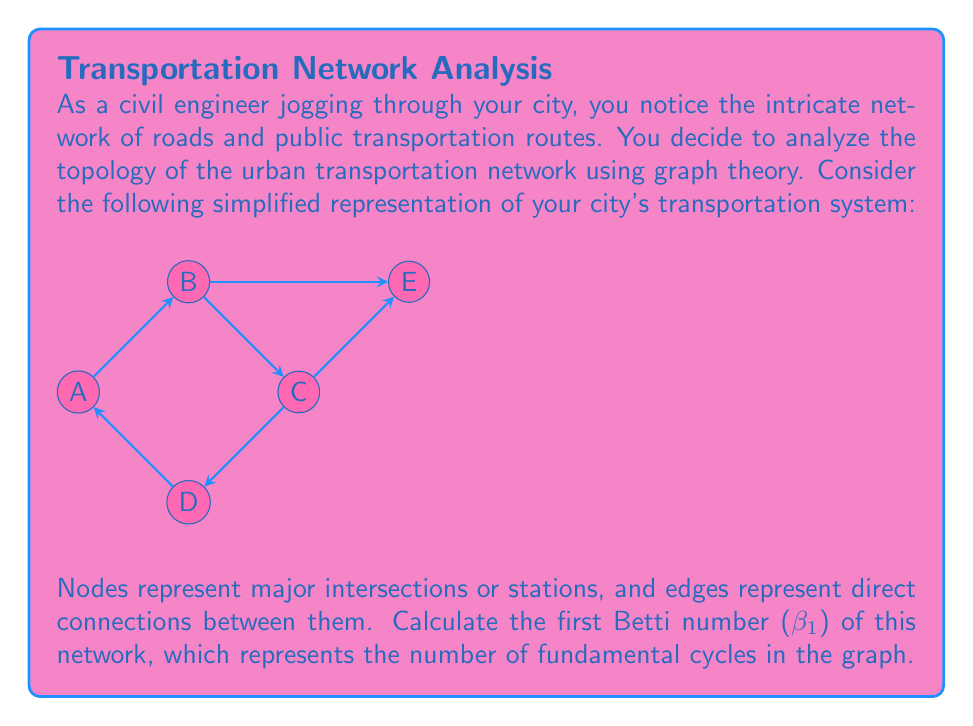Teach me how to tackle this problem. To calculate the first Betti number (β₁) of the graph, we'll follow these steps:

1. Recall the formula for the first Betti number of a graph:
   $$\beta_1 = |E| - |V| + 1$$
   where |E| is the number of edges and |V| is the number of vertices.

2. Count the number of vertices (|V|):
   The graph has 5 vertices (A, B, C, D, E).
   $$|V| = 5$$

3. Count the number of edges (|E|):
   The graph has 6 edges (A-B, B-C, C-D, D-A, B-E, C-E).
   $$|E| = 6$$

4. Apply the formula:
   $$\beta_1 = |E| - |V| + 1$$
   $$\beta_1 = 6 - 5 + 1$$
   $$\beta_1 = 2$$

5. Interpret the result:
   The first Betti number being 2 indicates that there are two fundamental cycles in the graph. These cycles correspond to the two loops in the transportation network: A-B-C-D-A and B-C-E-B.

This topological analysis provides insights into the redundancy and connectivity of the urban transportation network, which is crucial for civil engineering and urban planning considerations.
Answer: $$\beta_1 = 2$$ 